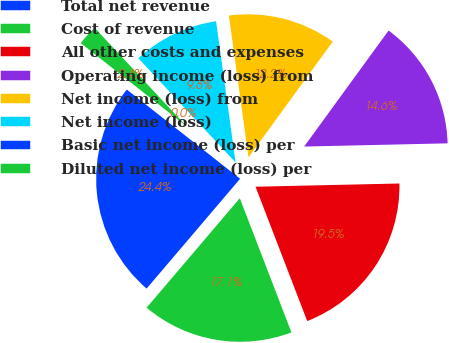<chart> <loc_0><loc_0><loc_500><loc_500><pie_chart><fcel>Total net revenue<fcel>Cost of revenue<fcel>All other costs and expenses<fcel>Operating income (loss) from<fcel>Net income (loss) from<fcel>Net income (loss)<fcel>Basic net income (loss) per<fcel>Diluted net income (loss) per<nl><fcel>24.39%<fcel>17.07%<fcel>19.51%<fcel>14.63%<fcel>12.2%<fcel>9.76%<fcel>0.0%<fcel>2.44%<nl></chart> 